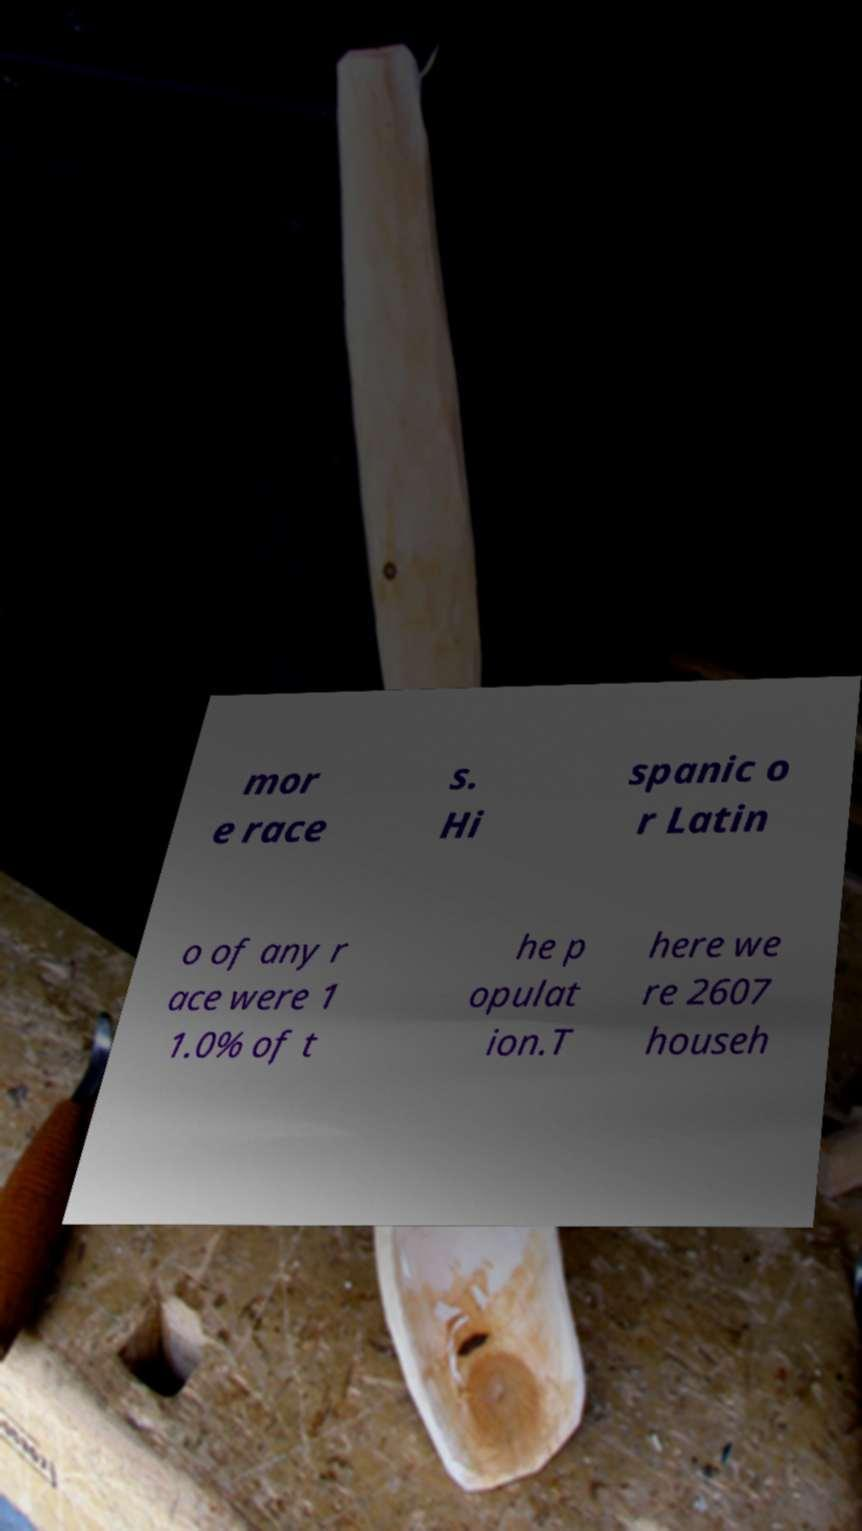Can you read and provide the text displayed in the image?This photo seems to have some interesting text. Can you extract and type it out for me? mor e race s. Hi spanic o r Latin o of any r ace were 1 1.0% of t he p opulat ion.T here we re 2607 househ 